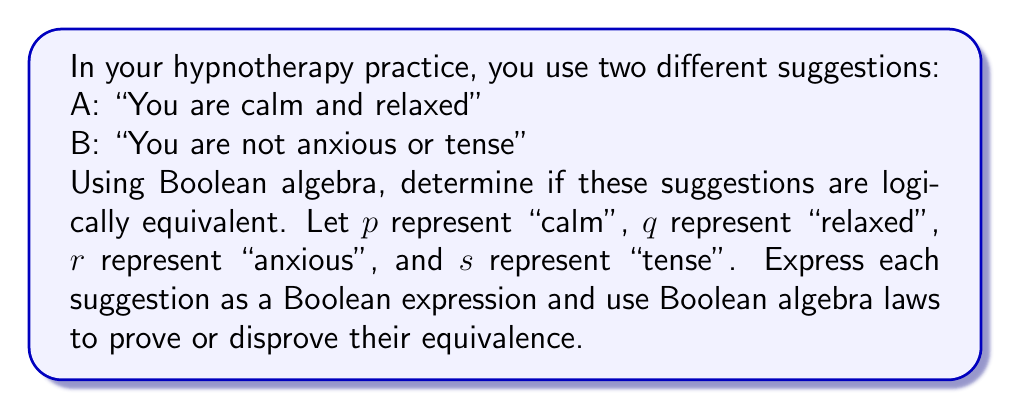Could you help me with this problem? 1. Express the suggestions as Boolean expressions:
   A: $p \land q$
   B: $\lnot(r \lor s)$

2. To prove equivalence, we need to show that A $\equiv$ B. Let's start with B and transform it:

3. Apply De Morgan's law to B:
   $\lnot(r \lor s) \equiv \lnot r \land \lnot s$

4. Now, we need to establish the relationship between the variables:
   calm (p) is the opposite of anxious (r), so $p \equiv \lnot r$
   relaxed (q) is the opposite of tense (s), so $q \equiv \lnot s$

5. Substitute these relationships into the expression from step 3:
   $\lnot r \land \lnot s \equiv p \land q$

6. This is exactly the same as expression A, which proves that A and B are logically equivalent.

Therefore, "You are calm and relaxed" is logically equivalent to "You are not anxious or tense" in Boolean algebra.
Answer: A $\equiv$ B 